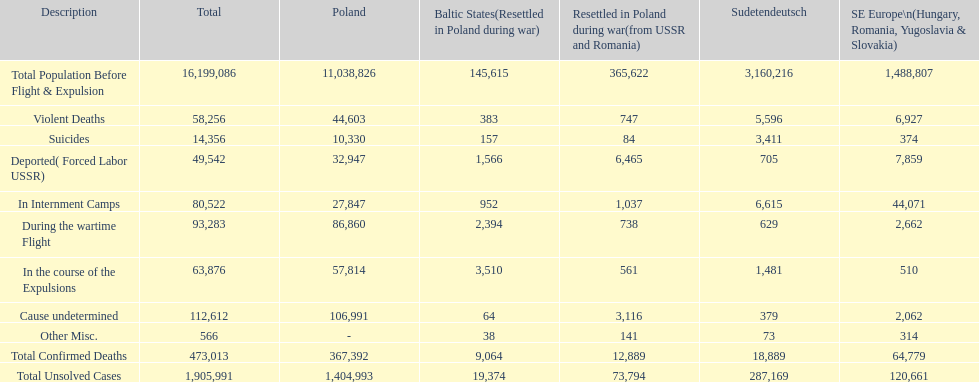In which district were the fewest unsolved cases recorded? Baltic States(Resettled in Poland during war). 